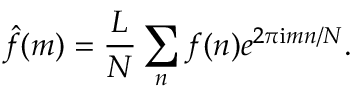<formula> <loc_0><loc_0><loc_500><loc_500>\hat { f } ( m ) = \frac { L } { N } \sum _ { n } f ( n ) e ^ { 2 \pi i m n / N } .</formula> 